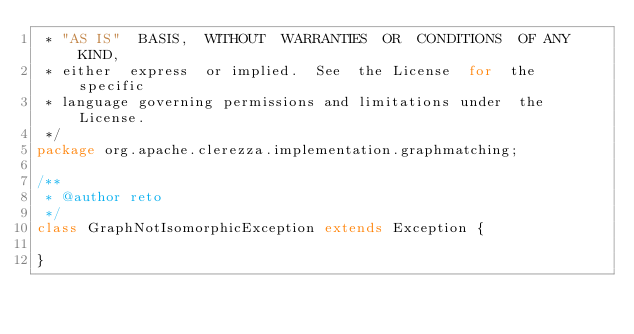Convert code to text. <code><loc_0><loc_0><loc_500><loc_500><_Java_> * "AS IS"  BASIS,  WITHOUT  WARRANTIES  OR  CONDITIONS  OF ANY KIND,
 * either  express  or implied.  See  the License  for  the  specific
 * language governing permissions and limitations under  the License.
 */
package org.apache.clerezza.implementation.graphmatching;

/**
 * @author reto
 */
class GraphNotIsomorphicException extends Exception {

}
</code> 